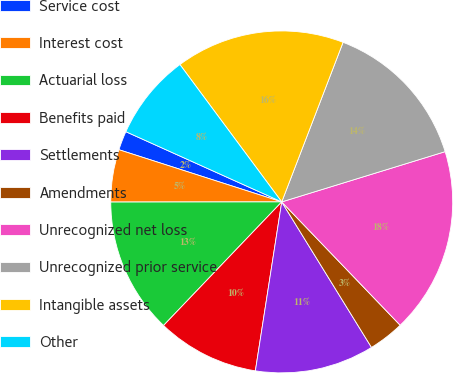Convert chart. <chart><loc_0><loc_0><loc_500><loc_500><pie_chart><fcel>Service cost<fcel>Interest cost<fcel>Actuarial loss<fcel>Benefits paid<fcel>Settlements<fcel>Amendments<fcel>Unrecognized net loss<fcel>Unrecognized prior service<fcel>Intangible assets<fcel>Other<nl><fcel>1.8%<fcel>4.95%<fcel>12.84%<fcel>9.68%<fcel>11.26%<fcel>3.38%<fcel>17.57%<fcel>14.41%<fcel>15.99%<fcel>8.11%<nl></chart> 